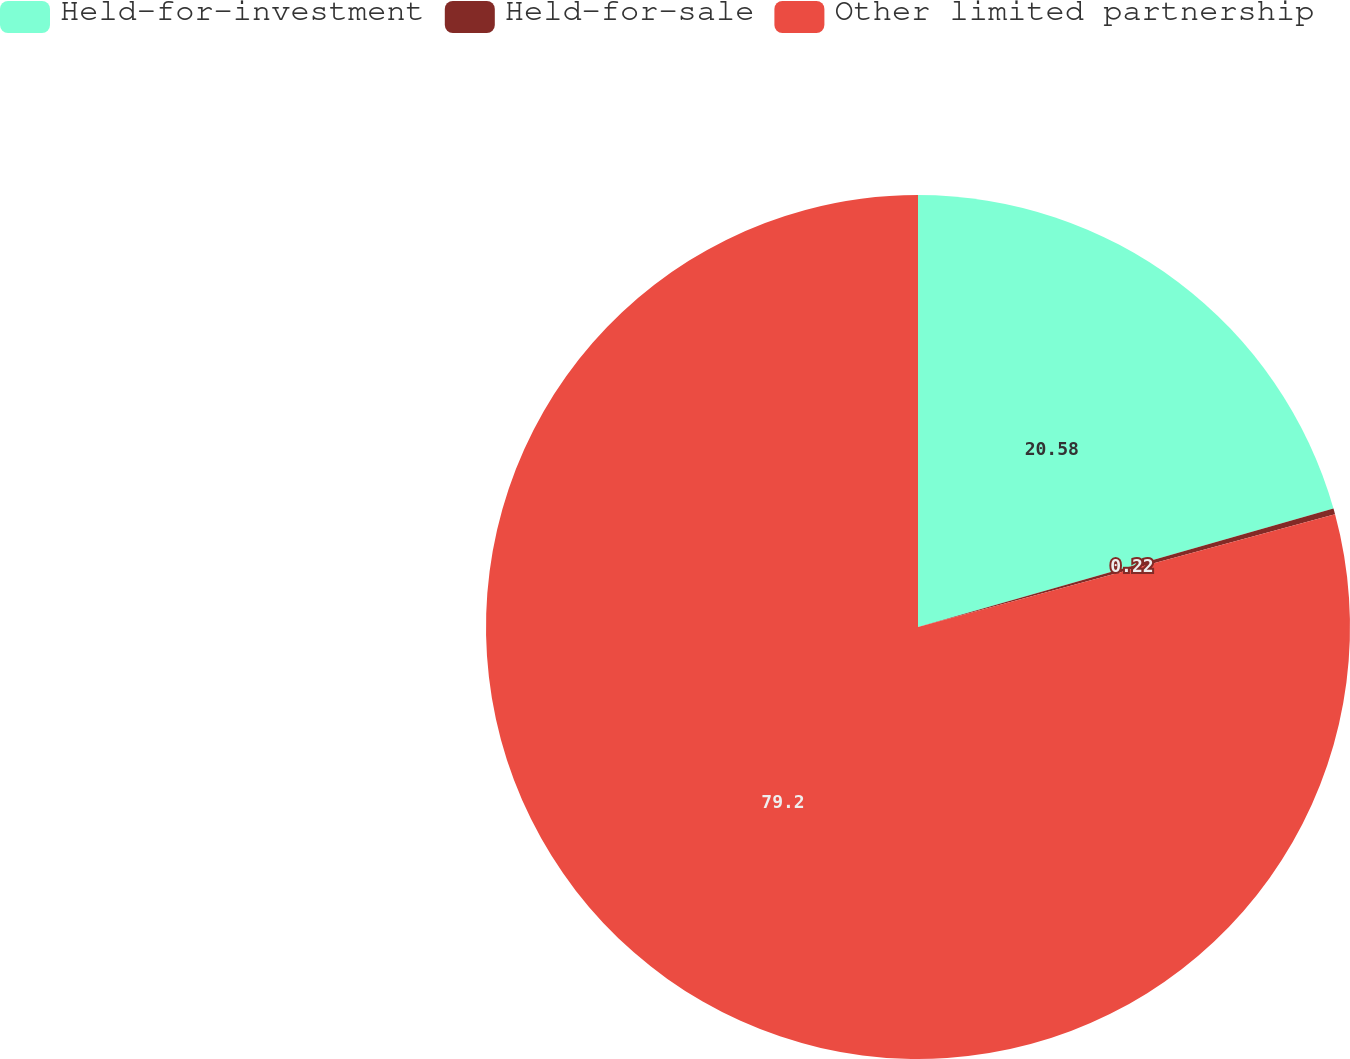Convert chart. <chart><loc_0><loc_0><loc_500><loc_500><pie_chart><fcel>Held-for-investment<fcel>Held-for-sale<fcel>Other limited partnership<nl><fcel>20.58%<fcel>0.22%<fcel>79.19%<nl></chart> 